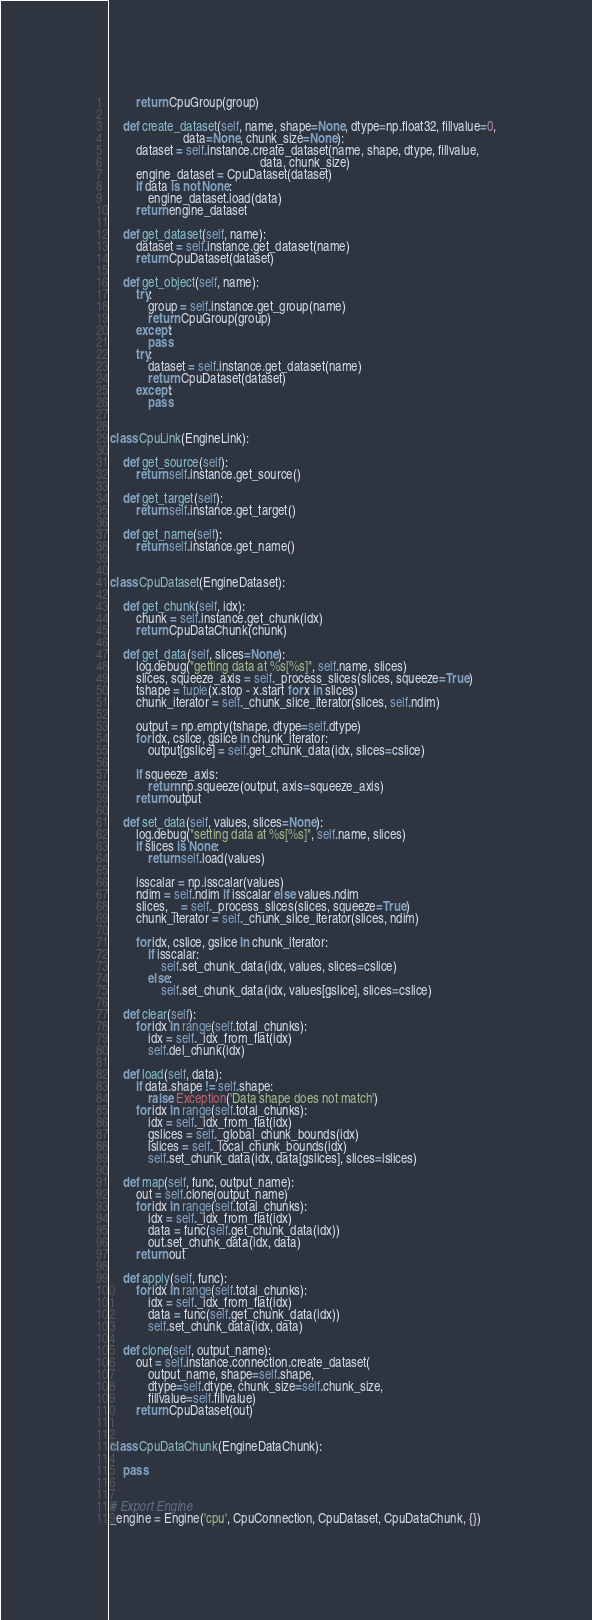Convert code to text. <code><loc_0><loc_0><loc_500><loc_500><_Python_>        return CpuGroup(group)

    def create_dataset(self, name, shape=None, dtype=np.float32, fillvalue=0,
                       data=None, chunk_size=None):
        dataset = self.instance.create_dataset(name, shape, dtype, fillvalue,
                                               data, chunk_size)
        engine_dataset = CpuDataset(dataset)
        if data is not None:
            engine_dataset.load(data)
        return engine_dataset
    
    def get_dataset(self, name):
        dataset = self.instance.get_dataset(name)
        return CpuDataset(dataset)

    def get_object(self, name):
        try:
            group = self.instance.get_group(name)
            return CpuGroup(group)
        except:
            pass
        try:
            dataset = self.instance.get_dataset(name)
            return CpuDataset(dataset)
        except:
            pass


class CpuLink(EngineLink):
    
    def get_source(self):
        return self.instance.get_source()
    
    def get_target(self):
        return self.instance.get_target()
    
    def get_name(self):
        return self.instance.get_name()


class CpuDataset(EngineDataset):

    def get_chunk(self, idx):
        chunk = self.instance.get_chunk(idx)
        return CpuDataChunk(chunk)

    def get_data(self, slices=None):
        log.debug("getting data at %s[%s]", self.name, slices)
        slices, squeeze_axis = self._process_slices(slices, squeeze=True)
        tshape = tuple(x.stop - x.start for x in slices)
        chunk_iterator = self._chunk_slice_iterator(slices, self.ndim)

        output = np.empty(tshape, dtype=self.dtype)
        for idx, cslice, gslice in chunk_iterator:
            output[gslice] = self.get_chunk_data(idx, slices=cslice)

        if squeeze_axis:
            return np.squeeze(output, axis=squeeze_axis)
        return output

    def set_data(self, values, slices=None):
        log.debug("setting data at %s[%s]", self.name, slices)
        if slices is None:
            return self.load(values)

        isscalar = np.isscalar(values)
        ndim = self.ndim if isscalar else values.ndim
        slices, _ = self._process_slices(slices, squeeze=True)
        chunk_iterator = self._chunk_slice_iterator(slices, ndim)

        for idx, cslice, gslice in chunk_iterator:
            if isscalar:
                self.set_chunk_data(idx, values, slices=cslice)
            else:
                self.set_chunk_data(idx, values[gslice], slices=cslice)

    def clear(self):
        for idx in range(self.total_chunks):
            idx = self._idx_from_flat(idx)
            self.del_chunk(idx)

    def load(self, data):
        if data.shape != self.shape:
            raise Exception('Data shape does not match')
        for idx in range(self.total_chunks):
            idx = self._idx_from_flat(idx)
            gslices = self._global_chunk_bounds(idx)
            lslices = self._local_chunk_bounds(idx)
            self.set_chunk_data(idx, data[gslices], slices=lslices)

    def map(self, func, output_name):
        out = self.clone(output_name)
        for idx in range(self.total_chunks):
            idx = self._idx_from_flat(idx)
            data = func(self.get_chunk_data(idx))
            out.set_chunk_data(idx, data)
        return out

    def apply(self, func):
        for idx in range(self.total_chunks):
            idx = self._idx_from_flat(idx)
            data = func(self.get_chunk_data(idx))
            self.set_chunk_data(idx, data)

    def clone(self, output_name):
        out = self.instance.connection.create_dataset(
            output_name, shape=self.shape,
            dtype=self.dtype, chunk_size=self.chunk_size,
            fillvalue=self.fillvalue)
        return CpuDataset(out)


class CpuDataChunk(EngineDataChunk):

    pass


# Export Engine
_engine = Engine('cpu', CpuConnection, CpuDataset, CpuDataChunk, {})
</code> 